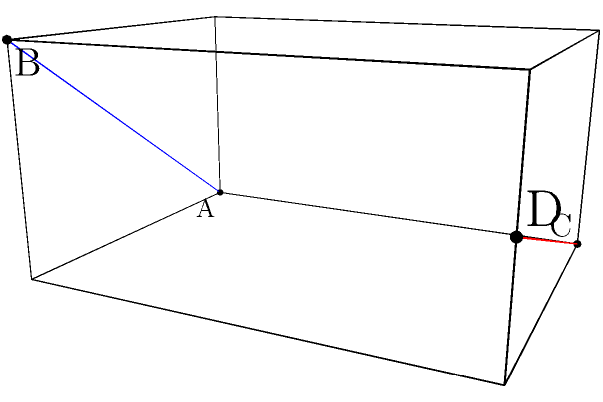In your latest novel, you describe a unique bookstore with a rectangular prism-shaped room. Two shelves, represented by skew lines AB and CD, run diagonally across the room. As the author, you want to determine the shortest distance between these shelves to ensure proper spacing. Given that the room measures 3 units in length, 4 units in width, and 2 units in height, with line AB running from (0,0,0) to (3,0,2) and line CD from (0,4,0) to (3,4,1), calculate the shortest distance between the two shelves. To find the shortest distance between two skew lines in a rectangular prism, we can follow these steps:

1) First, we need to find the direction vectors of the two lines:
   $\vec{u} = \overrightarrow{AB} = (3-0, 0-0, 2-0) = (3, 0, 2)$
   $\vec{v} = \overrightarrow{CD} = (3-0, 4-4, 1-0) = (3, 0, 1)$

2) Next, we calculate the cross product of these vectors:
   $\vec{n} = \vec{u} \times \vec{v} = (0\cdot1 - 2\cdot0, 2\cdot3 - 3\cdot1, 3\cdot0 - 0\cdot3) = (0, 3, 0)$

3) We then find a vector connecting any point on one line to any point on the other line:
   $\vec{w} = \overrightarrow{AC} = (0-0, 4-0, 0-0) = (0, 4, 0)$

4) The shortest distance is given by the formula:
   $d = \frac{|\vec{w} \cdot \vec{n}|}{|\vec{n}|}$

5) Calculating the dot product in the numerator:
   $\vec{w} \cdot \vec{n} = 0\cdot0 + 4\cdot3 + 0\cdot0 = 12$

6) The magnitude of $\vec{n}$ is:
   $|\vec{n}| = \sqrt{0^2 + 3^2 + 0^2} = 3$

7) Therefore, the shortest distance is:
   $d = \frac{|12|}{3} = 4$

Thus, the shortest distance between the two shelves is 4 units.
Answer: 4 units 